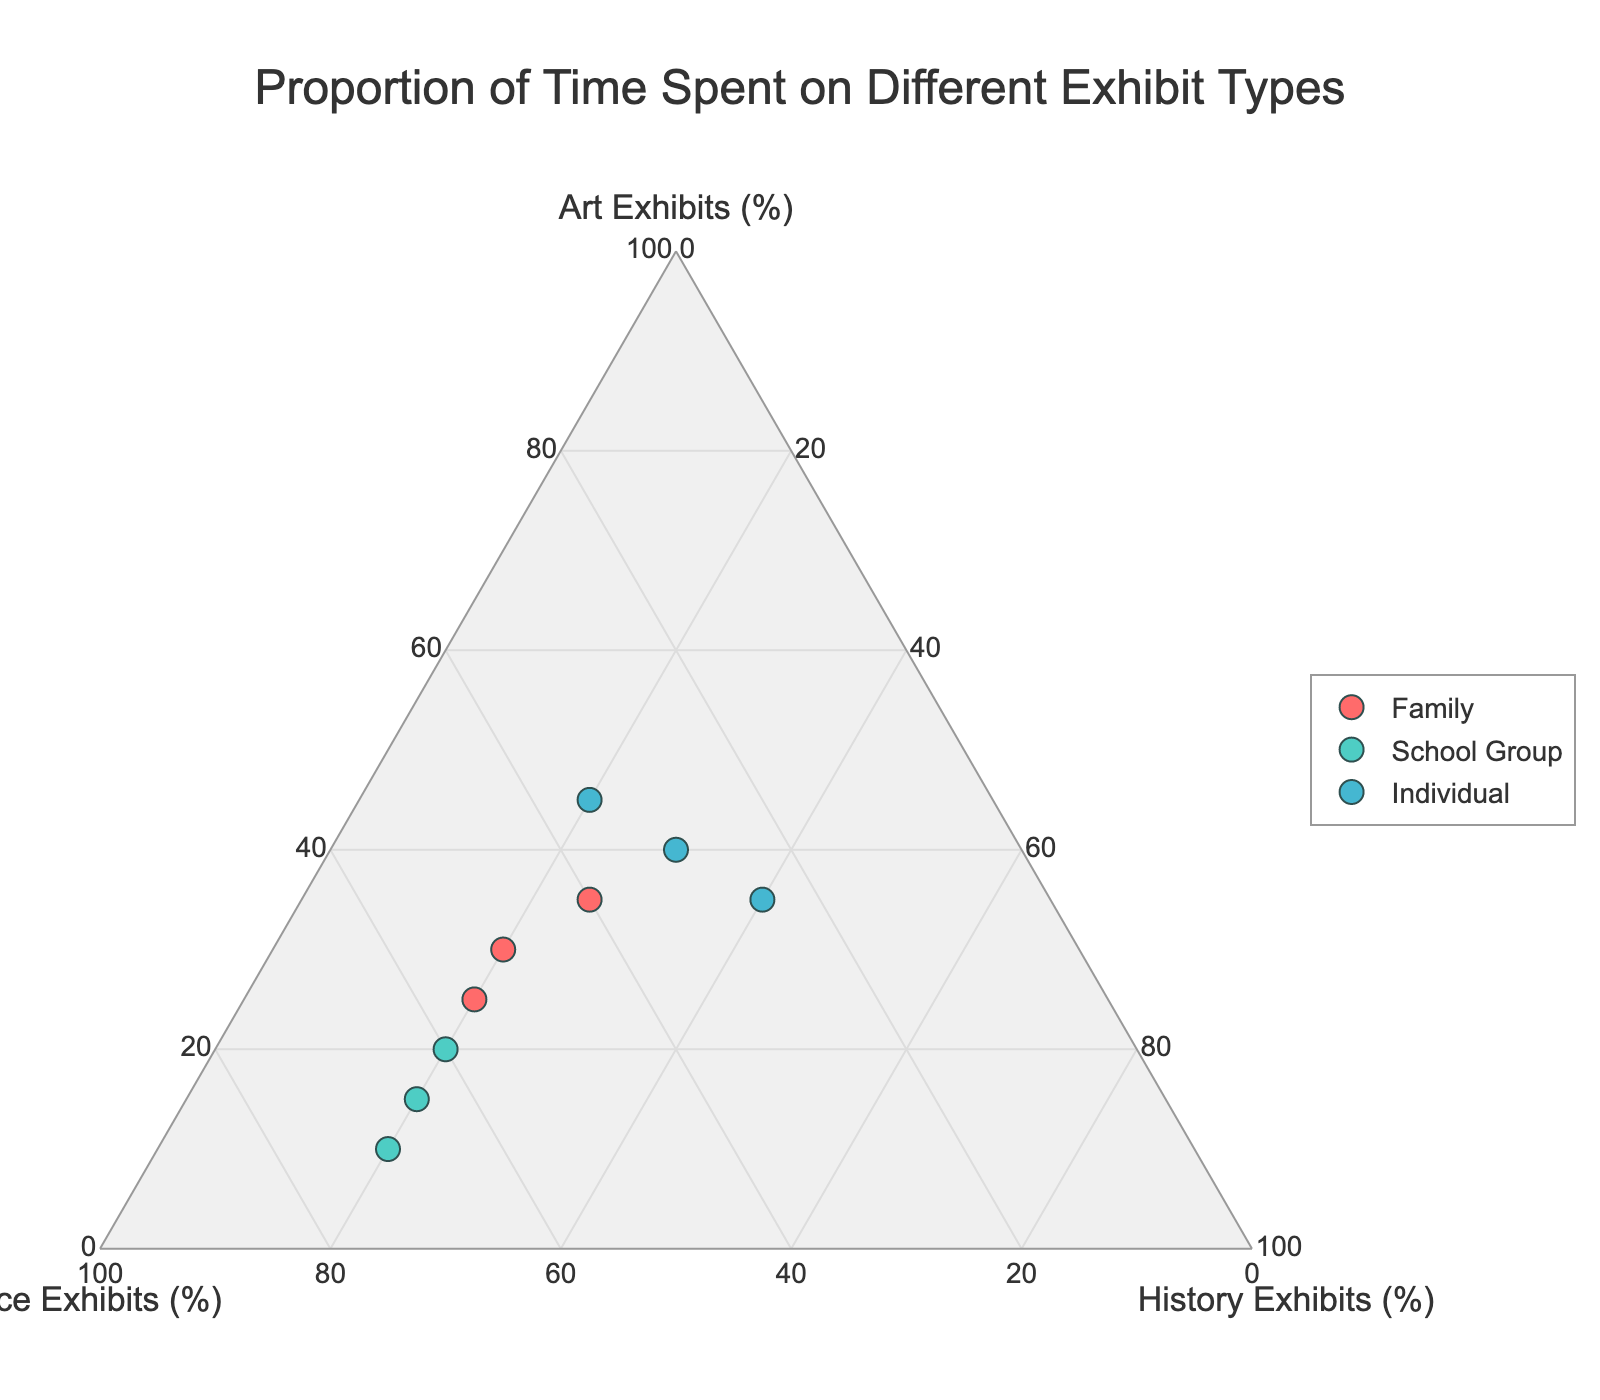What is the title of the plot? The title of the plot is located at the top center of the figure. It states the main purpose of the plot, which is to show the proportions of time spent by different visitor groups on various types of exhibits.
Answer: Proportion of Time Spent on Different Exhibit Types How many data points represent the 'Family' group? By examining the legend and the plot, we can see that data points representing the 'Family' group are marked with circles in a specific color. Counting these helps determine the number of data points.
Answer: 3 Which visitor group appears to spend the highest proportion of time on art exhibits? By comparing the positions of data points, we see that the data points representing the 'Individual' group are closest to the vertex labeled 'Art Exhibits (%),' indicating the highest proportion.
Answer: Individual What is the range of proportions spent on science exhibits by the 'School Group'? To find the range, we look at the maximum and minimum values observed for the 'School Group' data points along the 'Science Exhibits (%)' axis. These values can then be used to calculate the range.
Answer: 60%-70% Which visitor group's data points are most evenly spread across the three exhibit types? This requires observing the distribution of data points for each group. The 'Family' group's data points are more evenly distributed along the three vertices, indicating a balanced distribution.
Answer: Family Compare the average proportion of time spent on 'Science Exhibits' by 'Family' and 'School Group'. Calculate the average proportion by summing the 'Science Exhibits (%)' values for each group and dividing by the number of data points. For 'Family': (50 + 55 + 40)/3 = 48.33%. For 'School Group': (60 + 65 + 70)/3 = 65%.
Answer: Family: 48.33%, School Group: 65% What is the combined proportion of time spent on 'Art Exhibits' and 'History Exhibits' for the 'Individual' group? This involves summing the proportions of time spent on 'Art Exhibits (%)' and 'History Exhibits (%)' for each data point and averaging them. The sum for each point is (40+30, 35+40, 45+20), which gives an average of (70, 75, 65)/3.
Answer: 70% Are there any visitor groups that show a consistent pattern in their exhibit visit proportions? Consistency can be evaluated by observing if the data points for any group cluster closely together without large deviations. The 'School Group' shows a consistent pattern with a high proportion of time spent on 'Science Exhibits.'
Answer: School Group 